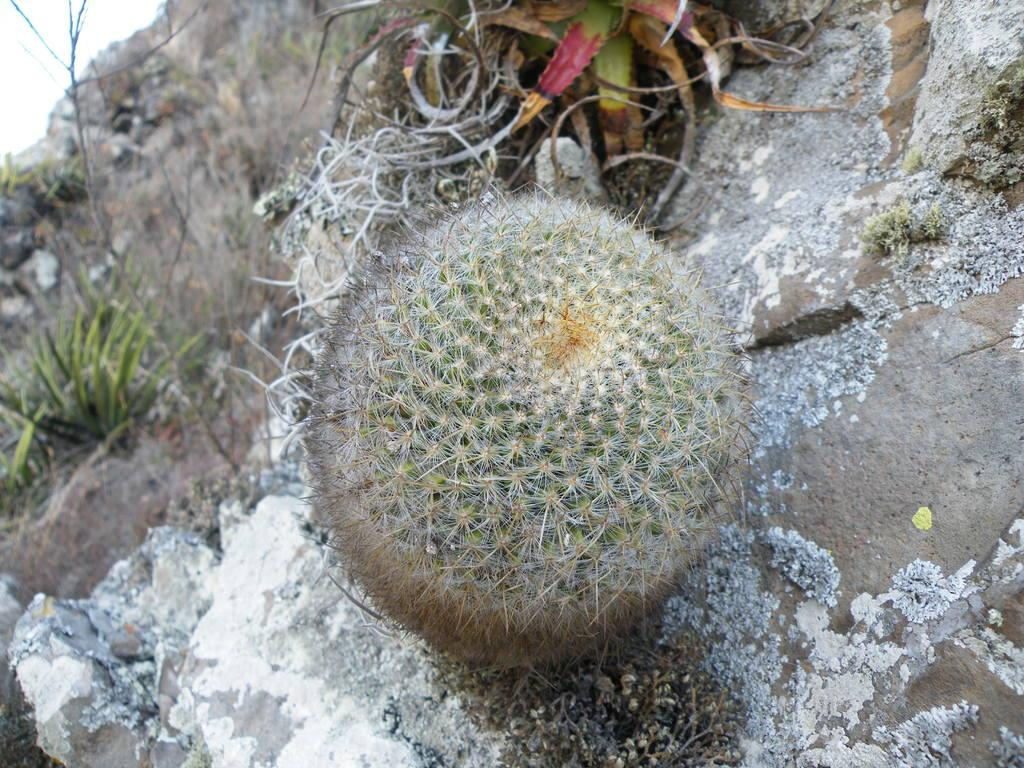What type of plant is in the foreground of the image? There is a desert plant in the foreground of the image. What else can be seen in the foreground of the image? There are stones in the foreground of the image. What is visible in the background of the image? There are plants and the sky visible in the background of the image. What type of letter is being delivered in the image? There is no letter or delivery person present in the image. What is being served for dinner in the image? There is no dinner or food being served in the image. 